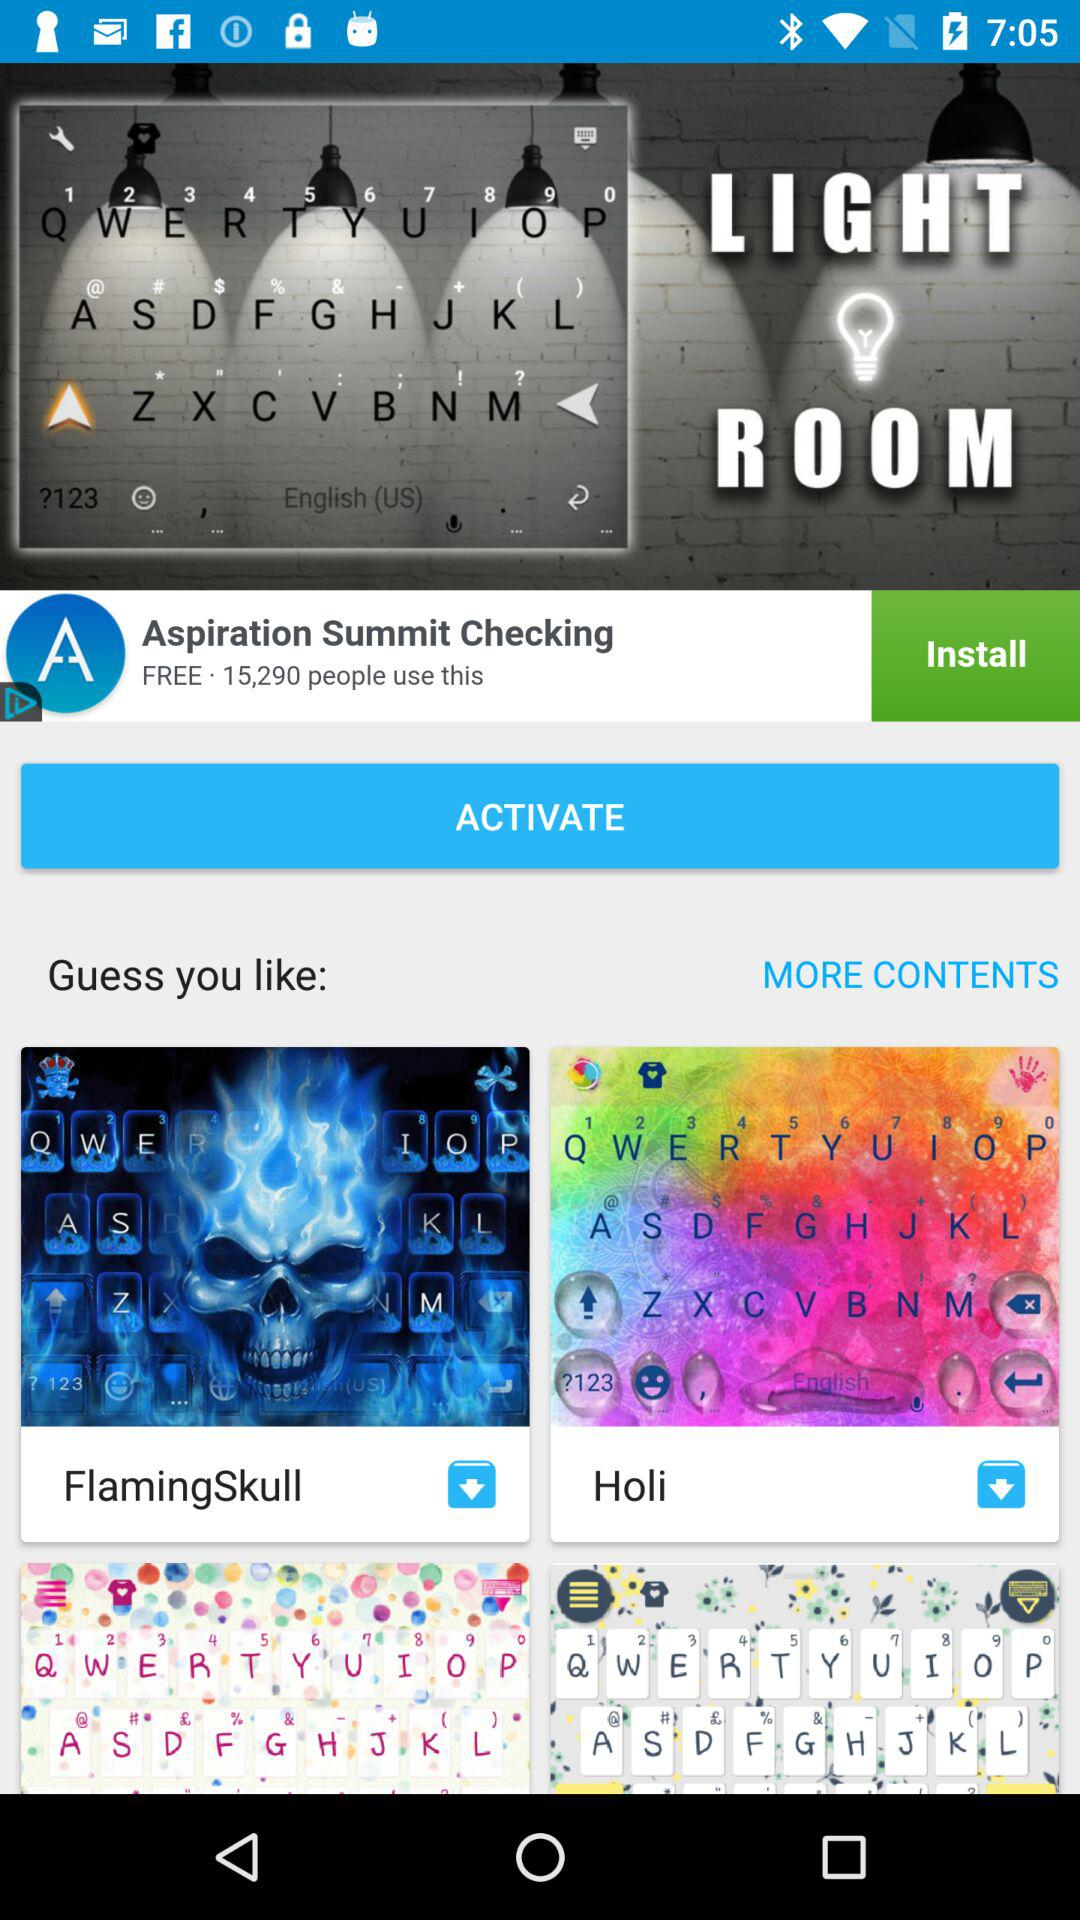Which keyboard has the most downloads?
Answer the question using a single word or phrase. Aspiration Summit Checking 